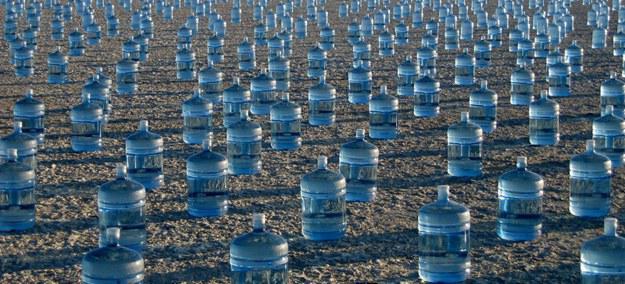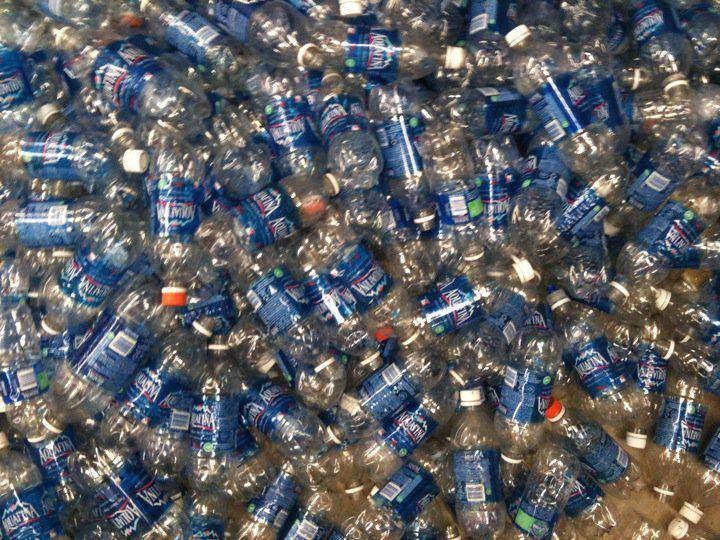The first image is the image on the left, the second image is the image on the right. Evaluate the accuracy of this statement regarding the images: "At least one image contains small water bottles arranged in neat rows.". Is it true? Answer yes or no. No. The first image is the image on the left, the second image is the image on the right. For the images displayed, is the sentence "One image shows water bottles in multiple tiers." factually correct? Answer yes or no. No. 